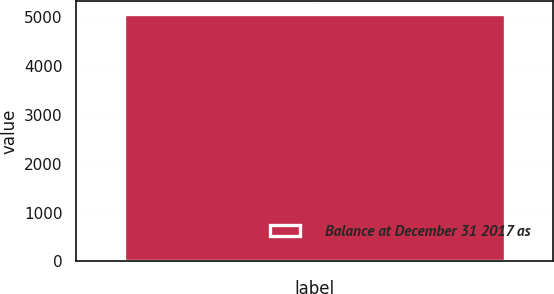Convert chart. <chart><loc_0><loc_0><loc_500><loc_500><bar_chart><fcel>Balance at December 31 2017 as<nl><fcel>5061.1<nl></chart> 